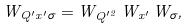<formula> <loc_0><loc_0><loc_500><loc_500>W _ { Q ^ { \prime } x ^ { \prime } \sigma } = W _ { Q ^ { \prime 2 } } \, W _ { x ^ { \prime } } \, W _ { \sigma } ,</formula> 